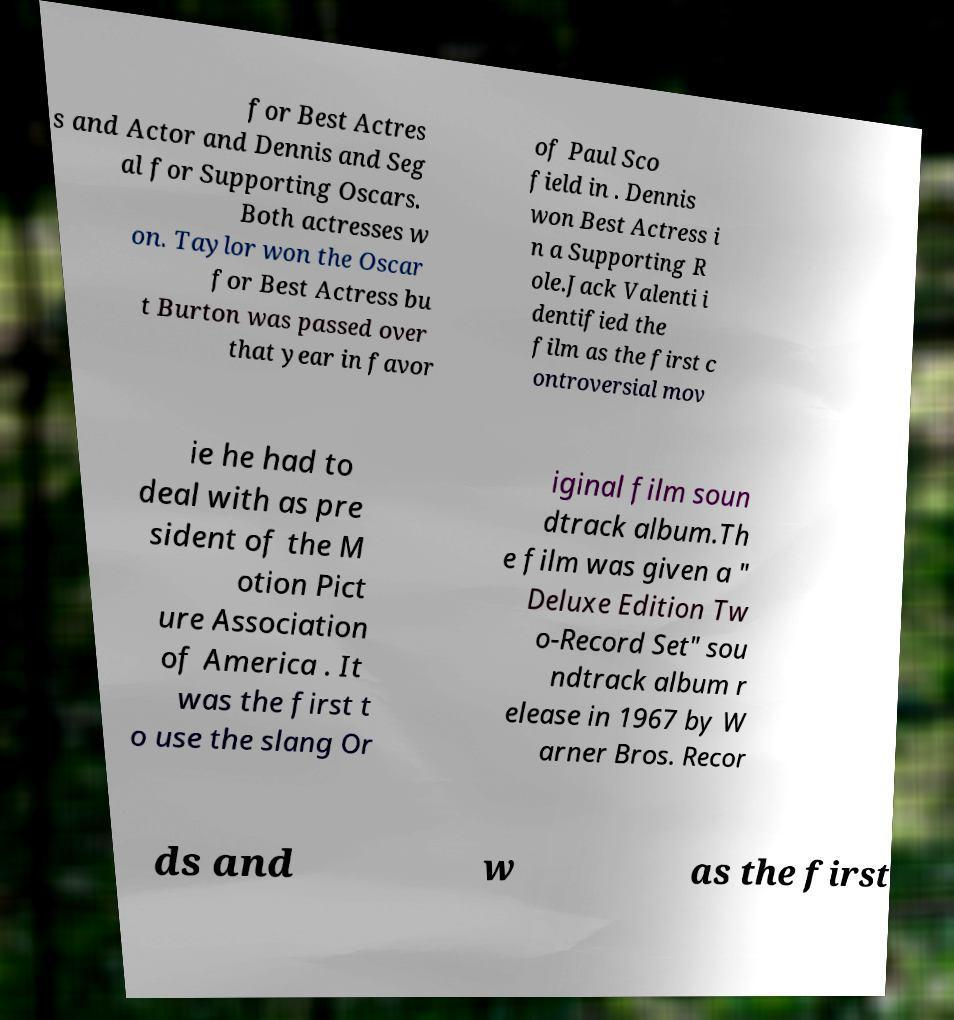Can you read and provide the text displayed in the image?This photo seems to have some interesting text. Can you extract and type it out for me? for Best Actres s and Actor and Dennis and Seg al for Supporting Oscars. Both actresses w on. Taylor won the Oscar for Best Actress bu t Burton was passed over that year in favor of Paul Sco field in . Dennis won Best Actress i n a Supporting R ole.Jack Valenti i dentified the film as the first c ontroversial mov ie he had to deal with as pre sident of the M otion Pict ure Association of America . It was the first t o use the slang Or iginal film soun dtrack album.Th e film was given a " Deluxe Edition Tw o-Record Set" sou ndtrack album r elease in 1967 by W arner Bros. Recor ds and w as the first 